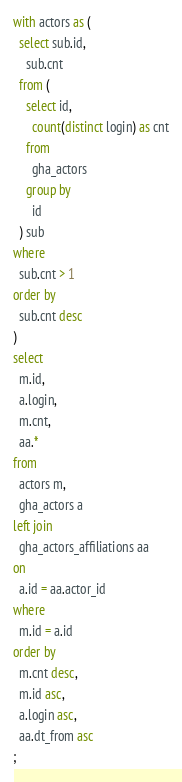<code> <loc_0><loc_0><loc_500><loc_500><_SQL_>with actors as (
  select sub.id,
    sub.cnt
  from (
    select id,
      count(distinct login) as cnt
    from
      gha_actors
    group by
      id
  ) sub
where
  sub.cnt > 1
order by
  sub.cnt desc
)
select
  m.id,
  a.login,
  m.cnt,
  aa.*
from
  actors m,
  gha_actors a
left join
  gha_actors_affiliations aa
on
  a.id = aa.actor_id
where
  m.id = a.id
order by
  m.cnt desc,
  m.id asc,
  a.login asc,
  aa.dt_from asc
;
</code> 